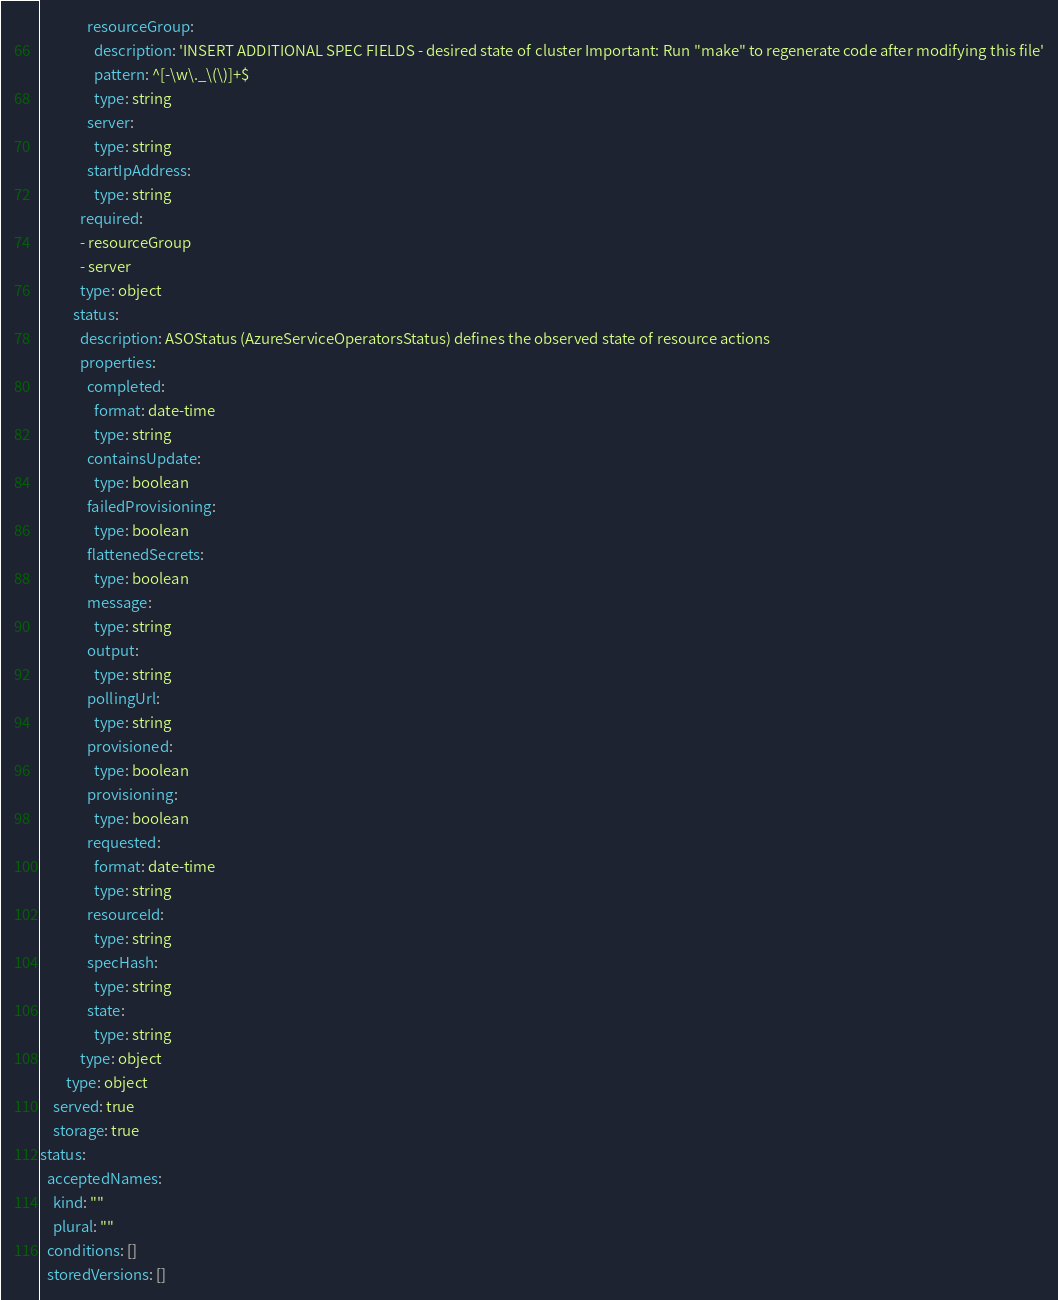Convert code to text. <code><loc_0><loc_0><loc_500><loc_500><_YAML_>              resourceGroup:
                description: 'INSERT ADDITIONAL SPEC FIELDS - desired state of cluster Important: Run "make" to regenerate code after modifying this file'
                pattern: ^[-\w\._\(\)]+$
                type: string
              server:
                type: string
              startIpAddress:
                type: string
            required:
            - resourceGroup
            - server
            type: object
          status:
            description: ASOStatus (AzureServiceOperatorsStatus) defines the observed state of resource actions
            properties:
              completed:
                format: date-time
                type: string
              containsUpdate:
                type: boolean
              failedProvisioning:
                type: boolean
              flattenedSecrets:
                type: boolean
              message:
                type: string
              output:
                type: string
              pollingUrl:
                type: string
              provisioned:
                type: boolean
              provisioning:
                type: boolean
              requested:
                format: date-time
                type: string
              resourceId:
                type: string
              specHash:
                type: string
              state:
                type: string
            type: object
        type: object
    served: true
    storage: true
status:
  acceptedNames:
    kind: ""
    plural: ""
  conditions: []
  storedVersions: []
</code> 